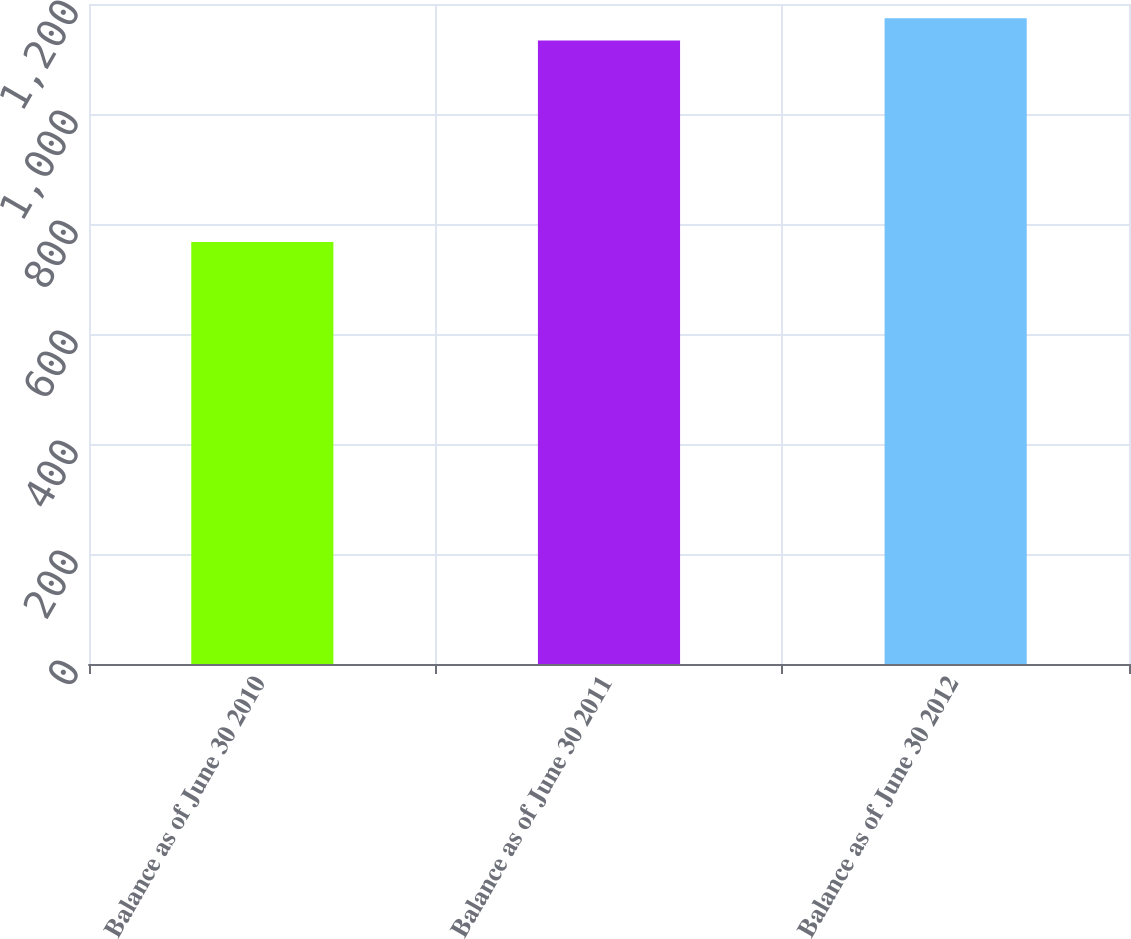Convert chart to OTSL. <chart><loc_0><loc_0><loc_500><loc_500><bar_chart><fcel>Balance as of June 30 2010<fcel>Balance as of June 30 2011<fcel>Balance as of June 30 2012<nl><fcel>767.2<fcel>1133.8<fcel>1174.04<nl></chart> 